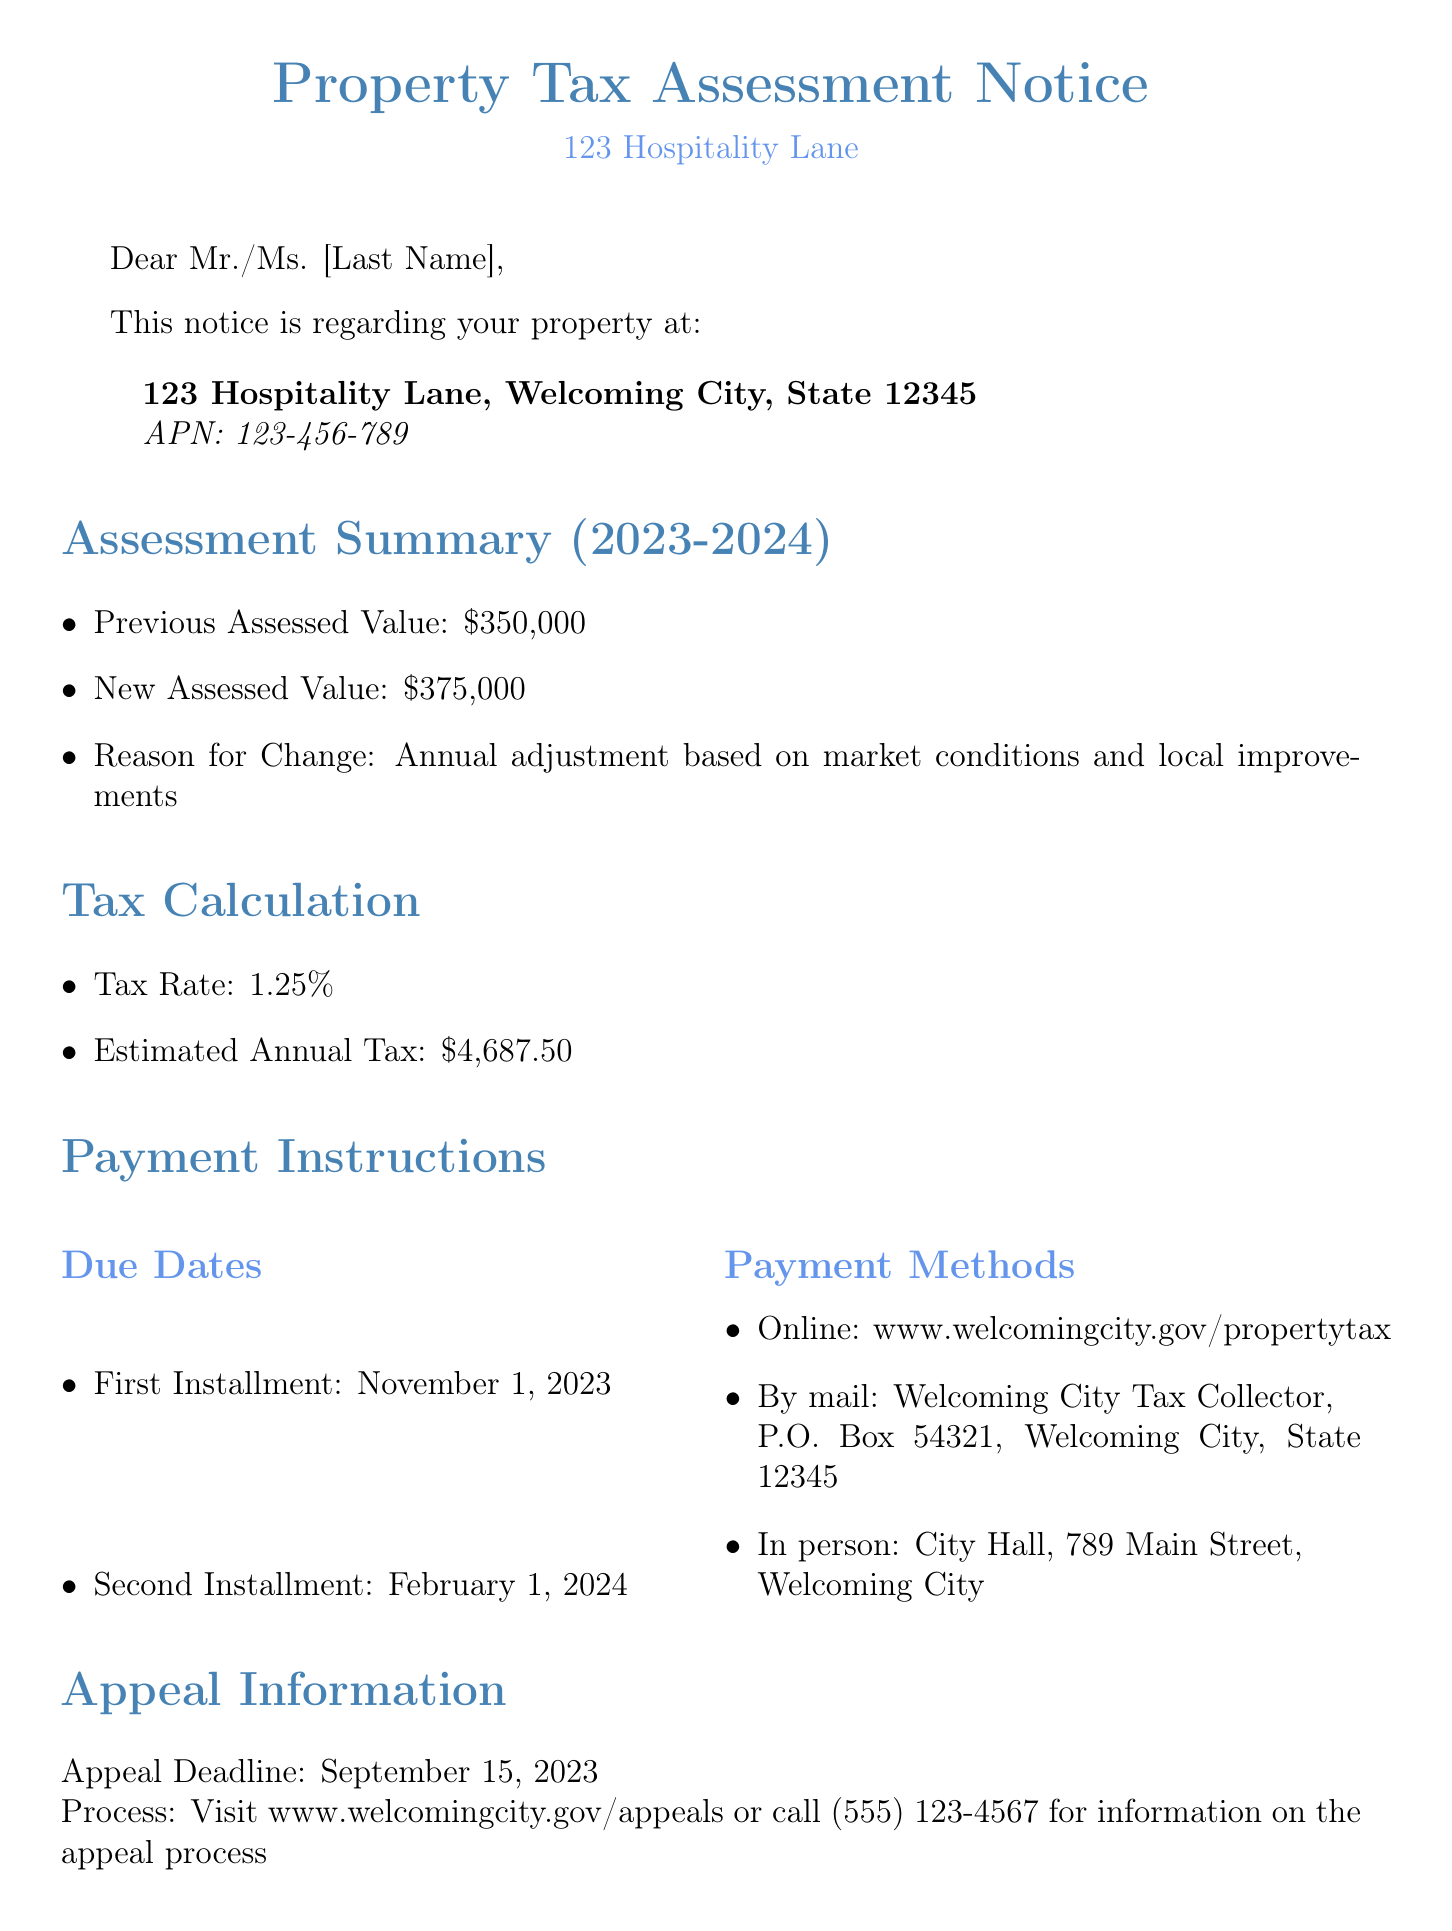What is the property address? The property address is specified clearly in the document, stating "123 Hospitality Lane, Welcoming City, State 12345."
Answer: 123 Hospitality Lane, Welcoming City, State 12345 What is the new assessed value? The new assessed value is directly provided in the assessment summary of the document as "$375,000."
Answer: $375,000 What is the tax rate? The tax rate is clearly mentioned in the tax calculation section as "1.25%."
Answer: 1.25% When is the first installment due? The due date for the first installment is explicitly stated in the payment instructions as "November 1, 2023."
Answer: November 1, 2023 What is the estimated annual tax? The estimated annual tax is calculated and provided in the document as "$4,687.50."
Answer: $4,687.50 What should a homeowner do if they want to appeal the assessment? The document outlines that for appeal information, one should visit a specific website or call a designated number.
Answer: Visit www.welcomingcity.gov/appeals or call (555) 123-4567 What impact might short-term rental income have? The document notifies that short-term rental income may influence future property assessments.
Answer: Future property assessments What is the appeal deadline? The document provides the deadline for submitting appeals clearly as "September 15, 2023."
Answer: September 15, 2023 Where can payments be made in person? The document specifies the location for in-person payments as "City Hall, 789 Main Street, Welcoming City."
Answer: City Hall, 789 Main Street, Welcoming City 